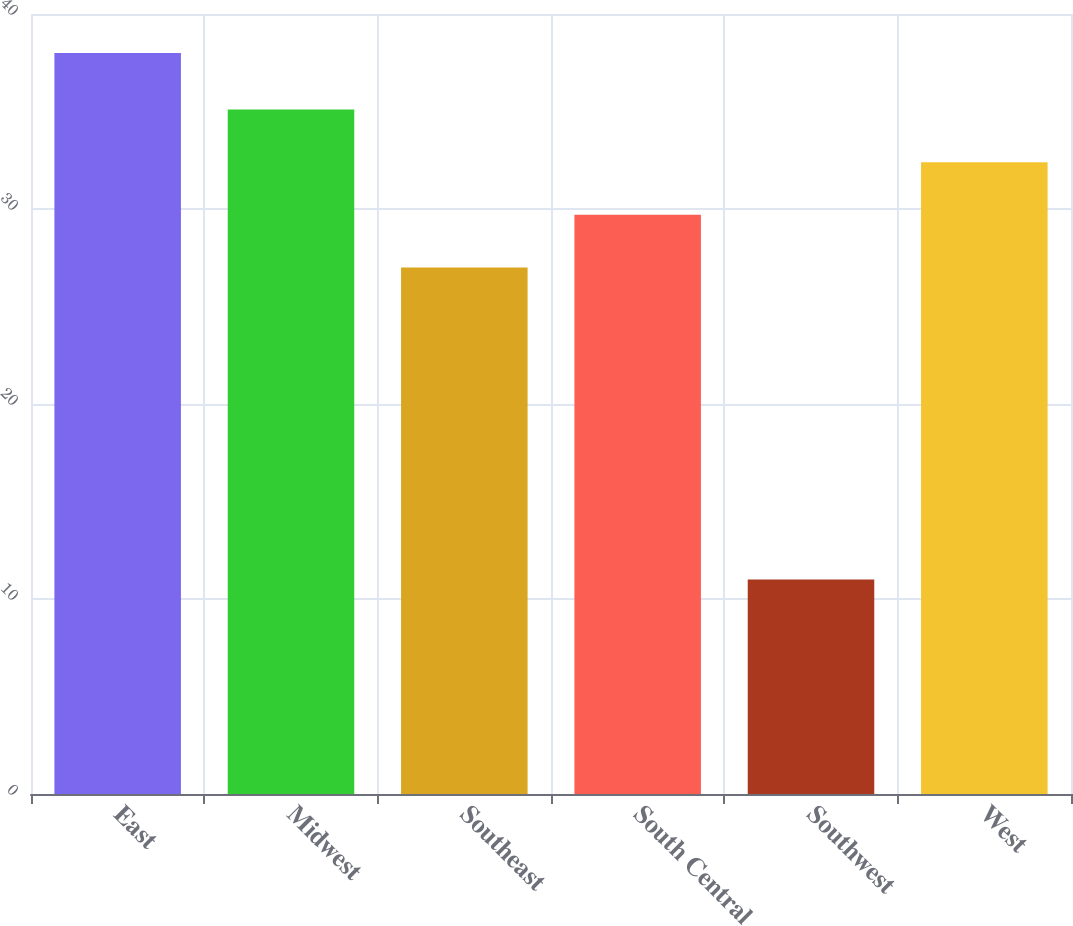Convert chart to OTSL. <chart><loc_0><loc_0><loc_500><loc_500><bar_chart><fcel>East<fcel>Midwest<fcel>Southeast<fcel>South Central<fcel>Southwest<fcel>West<nl><fcel>38<fcel>35.1<fcel>27<fcel>29.7<fcel>11<fcel>32.4<nl></chart> 